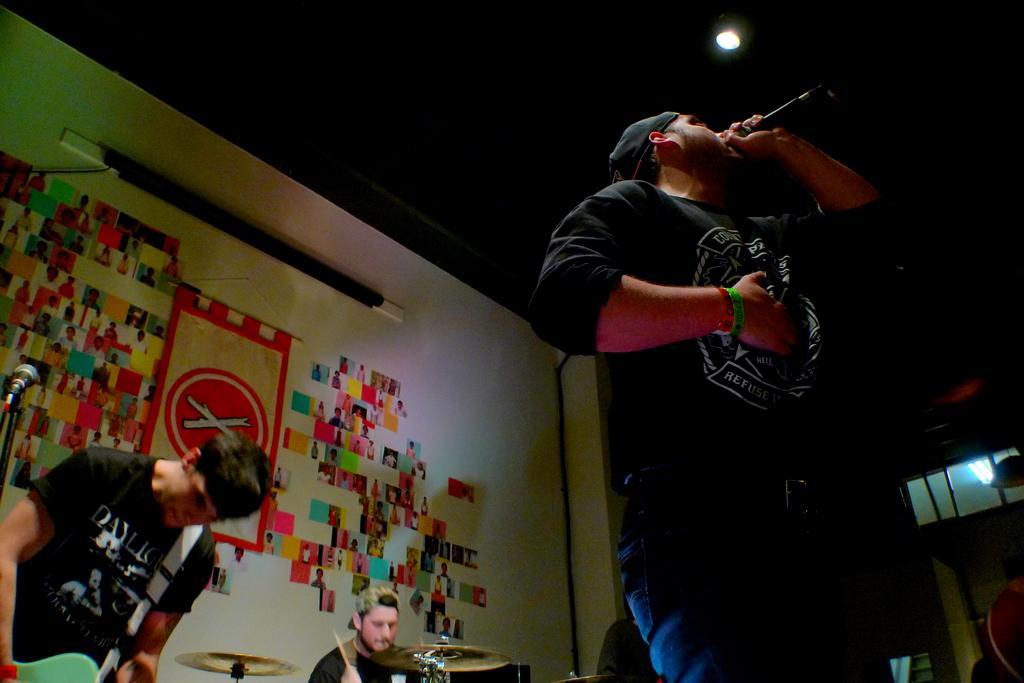In one or two sentences, can you explain what this image depicts? There is a man standing and holding a microphone and singing and these people are playing musical instruments. In the background we can see photos and banner on a wall. We can see lights. 